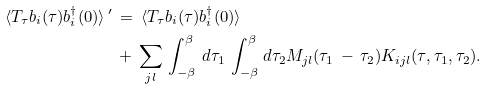<formula> <loc_0><loc_0><loc_500><loc_500>\, \langle T _ { \tau } b _ { i } ( \tau ) b ^ { \dagger } _ { i } ( 0 ) \rangle \, ^ { \prime } & \, = \, \langle T _ { \tau } b _ { i } ( \tau ) b ^ { \dagger } _ { i } ( 0 ) \rangle \\ \, & \, + \, \sum _ { j l } \, \int _ { - \beta } ^ { \beta } \, d \tau _ { 1 } \, \int _ { - \beta } ^ { \beta } d \tau _ { 2 } M _ { j l } ( \tau _ { 1 } \, - \, \tau _ { 2 } ) K _ { i j l } ( \tau , \tau _ { 1 } , \tau _ { 2 } ) .</formula> 